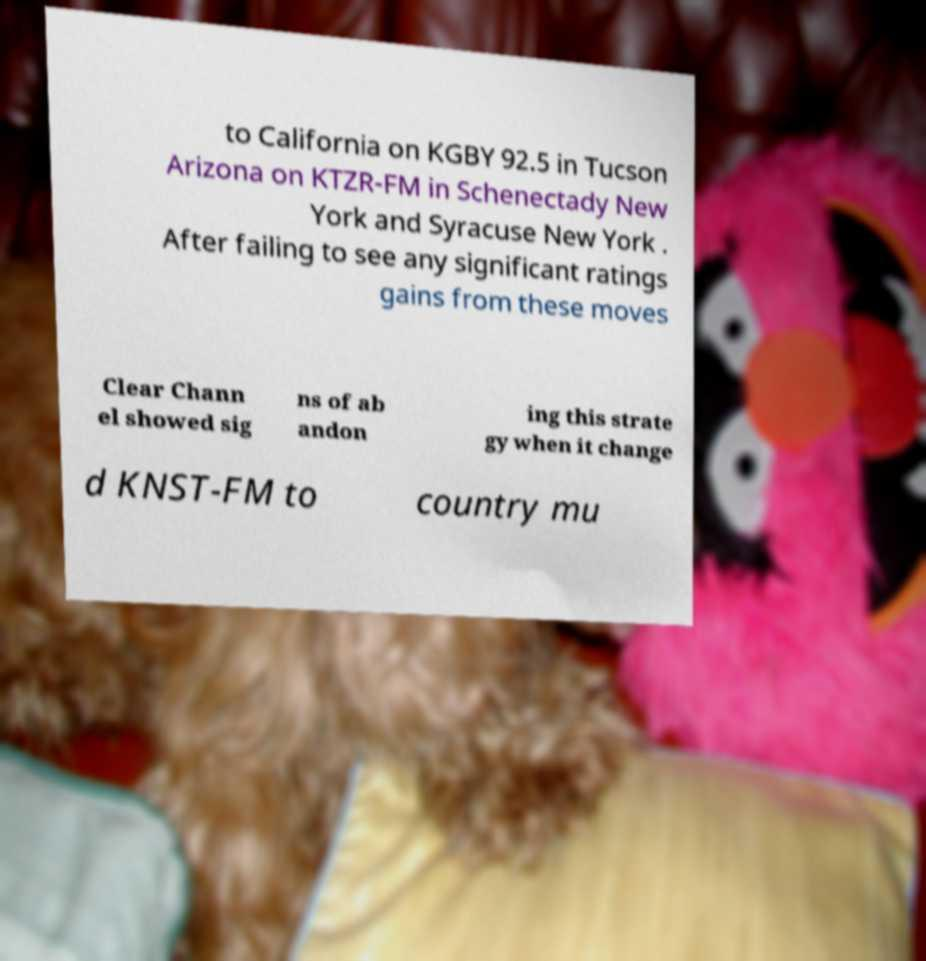Could you extract and type out the text from this image? to California on KGBY 92.5 in Tucson Arizona on KTZR-FM in Schenectady New York and Syracuse New York . After failing to see any significant ratings gains from these moves Clear Chann el showed sig ns of ab andon ing this strate gy when it change d KNST-FM to country mu 